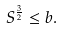<formula> <loc_0><loc_0><loc_500><loc_500>S ^ { \frac { 3 } { 2 } } \leq b .</formula> 